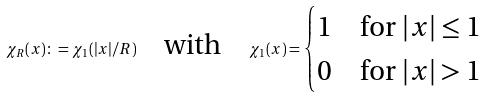<formula> <loc_0><loc_0><loc_500><loc_500>\chi _ { R } ( x ) \colon = \chi _ { 1 } ( | x | / R ) \quad \text {with} \quad \chi _ { 1 } ( x ) = \begin{cases} 1 & \text {for $|x|\leq 1$} \\ 0 & \text {for $|x|>1$} \end{cases}</formula> 